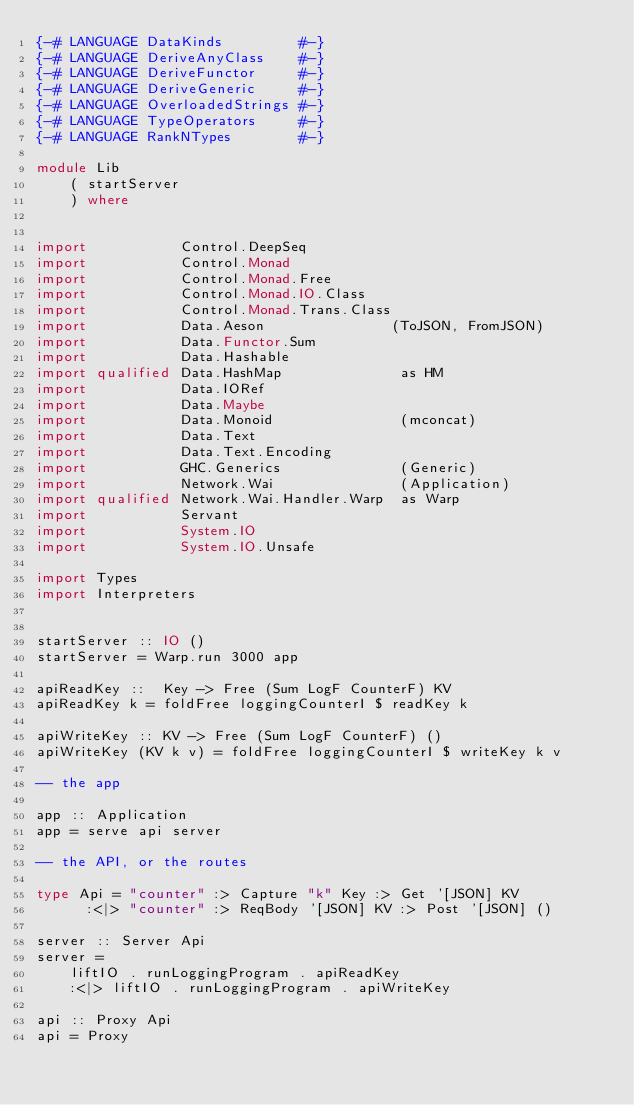<code> <loc_0><loc_0><loc_500><loc_500><_Haskell_>{-# LANGUAGE DataKinds         #-}
{-# LANGUAGE DeriveAnyClass    #-}
{-# LANGUAGE DeriveFunctor     #-}
{-# LANGUAGE DeriveGeneric     #-}
{-# LANGUAGE OverloadedStrings #-}
{-# LANGUAGE TypeOperators     #-}
{-# LANGUAGE RankNTypes        #-}

module Lib
    ( startServer
    ) where


import           Control.DeepSeq
import           Control.Monad
import           Control.Monad.Free
import           Control.Monad.IO.Class
import           Control.Monad.Trans.Class
import           Data.Aeson               (ToJSON, FromJSON)
import           Data.Functor.Sum
import           Data.Hashable
import qualified Data.HashMap              as HM
import           Data.IORef
import           Data.Maybe
import           Data.Monoid               (mconcat)
import           Data.Text
import           Data.Text.Encoding
import           GHC.Generics              (Generic)
import           Network.Wai               (Application)
import qualified Network.Wai.Handler.Warp  as Warp
import           Servant
import           System.IO
import           System.IO.Unsafe

import Types
import Interpreters


startServer :: IO ()
startServer = Warp.run 3000 app

apiReadKey ::  Key -> Free (Sum LogF CounterF) KV
apiReadKey k = foldFree loggingCounterI $ readKey k

apiWriteKey :: KV -> Free (Sum LogF CounterF) ()
apiWriteKey (KV k v) = foldFree loggingCounterI $ writeKey k v

-- the app

app :: Application
app = serve api server

-- the API, or the routes

type Api = "counter" :> Capture "k" Key :> Get '[JSON] KV
      :<|> "counter" :> ReqBody '[JSON] KV :> Post '[JSON] ()

server :: Server Api
server =
    liftIO . runLoggingProgram . apiReadKey
    :<|> liftIO . runLoggingProgram . apiWriteKey

api :: Proxy Api
api = Proxy
</code> 